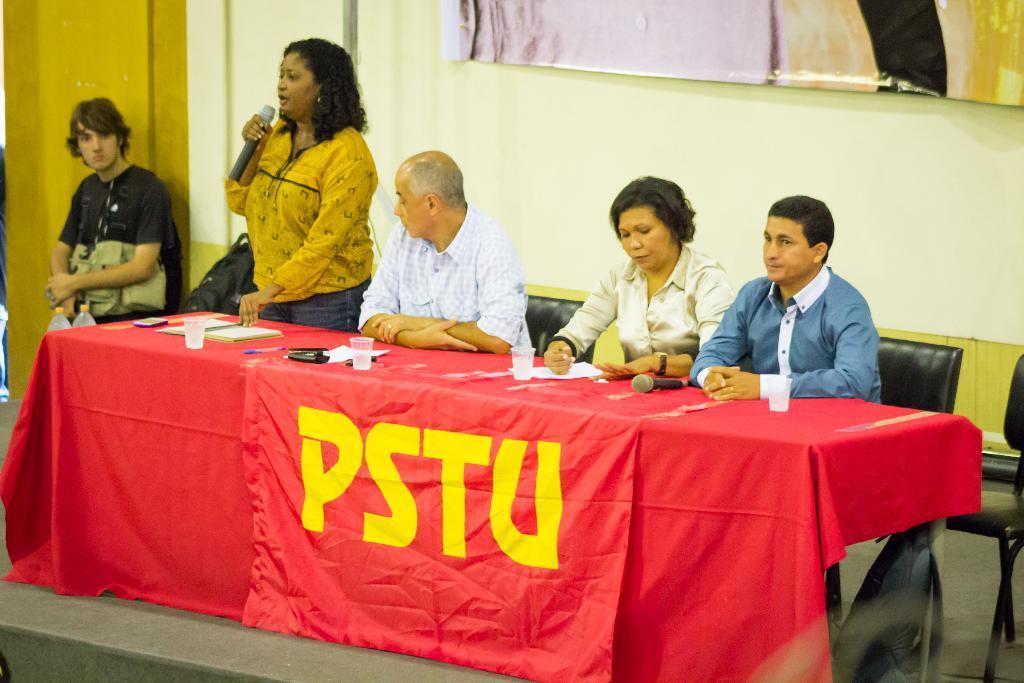Describe this image in one or two sentences. This is a picture taken in a room, there are a group of people sitting on a chair and a women in yellow dress standing and holding a microphone. In front of the people there is a table covered with red cloth on the table there is a cup, paper, pen and mobile. Background of this people is a wall. 